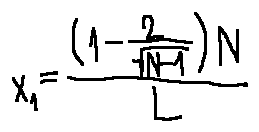<formula> <loc_0><loc_0><loc_500><loc_500>x _ { 1 } = \frac { ( 1 - \frac { 2 } { \sqrt { N - 1 } } ) N } { L }</formula> 